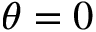Convert formula to latex. <formula><loc_0><loc_0><loc_500><loc_500>\theta = 0</formula> 